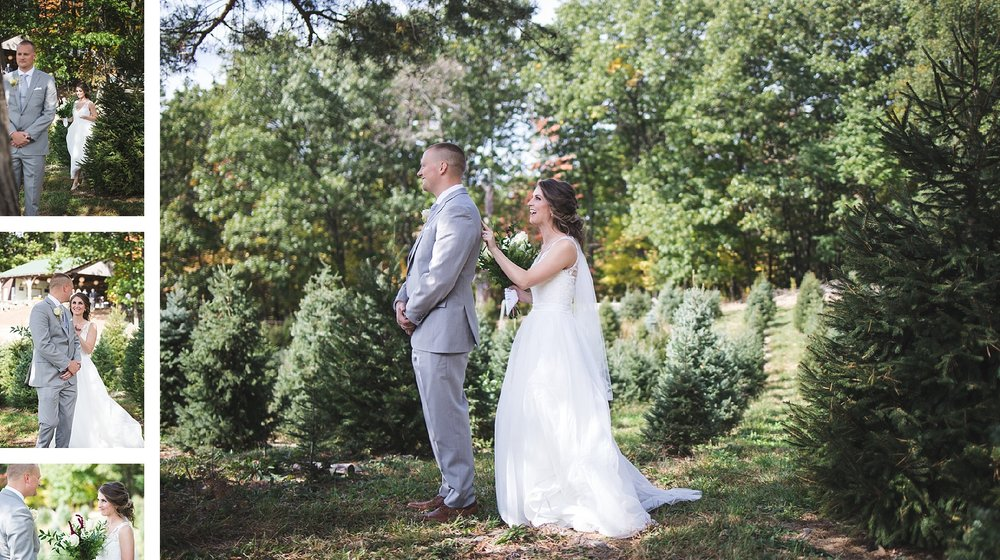Considering the setting and attire of the individuals, what time of year does this wedding likely take place, and what are the indicators of this in the image? The wedding likely takes place in late spring to early autumn. This is indicated by the full green leaves on the trees, the groom's choice of a light grey suit which is suitable for warmer weather, and the bride's sleeveless dress. Additionally, the bright sunlight and the flourishing greenery suggest a season where the weather is pleasant and the days are longer, typical of the timespan between late spring and early autumn. 